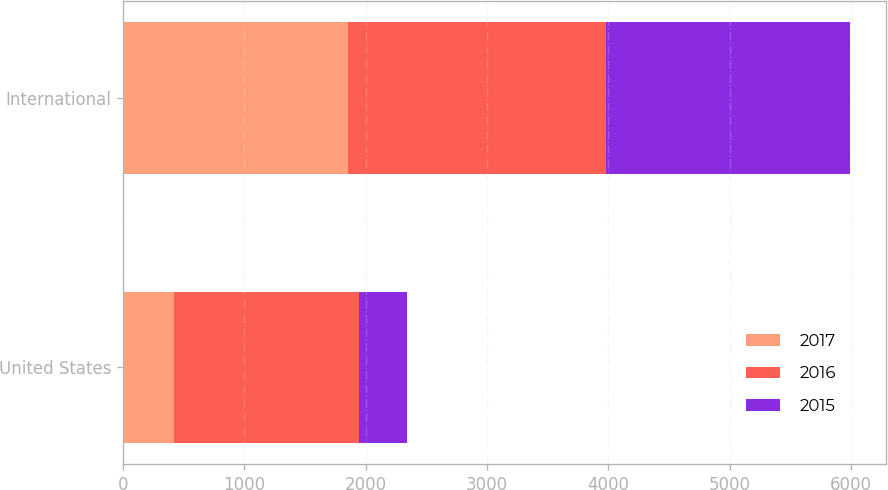Convert chart to OTSL. <chart><loc_0><loc_0><loc_500><loc_500><stacked_bar_chart><ecel><fcel>United States<fcel>International<nl><fcel>2017<fcel>418<fcel>1858<nl><fcel>2016<fcel>1529<fcel>2122<nl><fcel>2015<fcel>396<fcel>2010<nl></chart> 